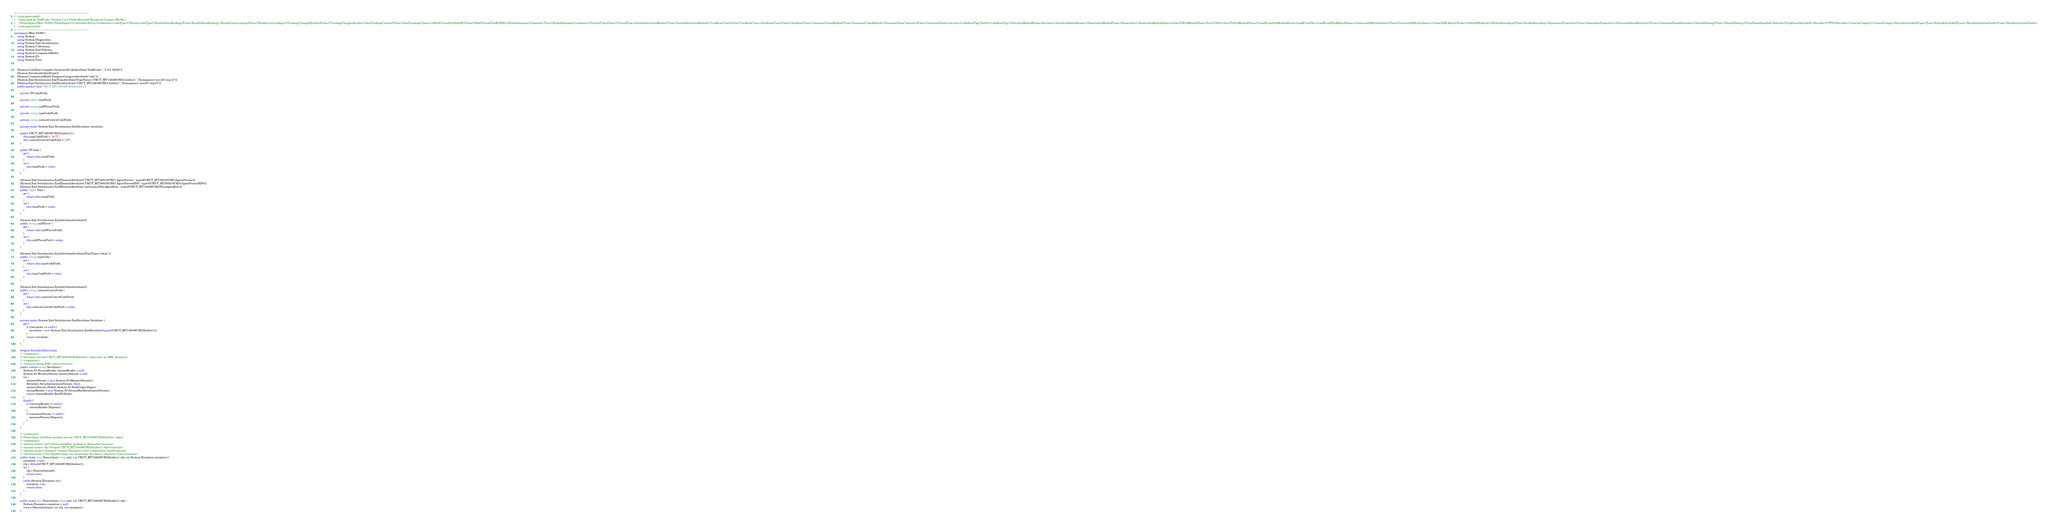Convert code to text. <code><loc_0><loc_0><loc_500><loc_500><_C#_>// ------------------------------------------------------------------------------
//  <auto-generated>
//    Generated by Xsd2Code. Version 3.4.0.18239 Microsoft Reciprocal License (Ms-RL) 
//    <NameSpace>Mim.V4200</NameSpace><Collection>Array</Collection><codeType>CSharp</codeType><EnableDataBinding>False</EnableDataBinding><EnableLazyLoading>False</EnableLazyLoading><TrackingChangesEnable>False</TrackingChangesEnable><GenTrackingClasses>False</GenTrackingClasses><HidePrivateFieldInIDE>False</HidePrivateFieldInIDE><EnableSummaryComment>True</EnableSummaryComment><VirtualProp>False</VirtualProp><IncludeSerializeMethod>True</IncludeSerializeMethod><UseBaseClass>False</UseBaseClass><GenBaseClass>False</GenBaseClass><GenerateCloneMethod>True</GenerateCloneMethod><GenerateDataContracts>False</GenerateDataContracts><CodeBaseTag>Net35</CodeBaseTag><SerializeMethodName>Serialize</SerializeMethodName><DeserializeMethodName>Deserialize</DeserializeMethodName><SaveToFileMethodName>SaveToFile</SaveToFileMethodName><LoadFromFileMethodName>LoadFromFile</LoadFromFileMethodName><GenerateXMLAttributes>True</GenerateXMLAttributes><OrderXMLAttrib>False</OrderXMLAttrib><EnableEncoding>False</EnableEncoding><AutomaticProperties>False</AutomaticProperties><GenerateShouldSerialize>False</GenerateShouldSerialize><DisableDebug>False</DisableDebug><PropNameSpecified>Default</PropNameSpecified><Encoder>UTF8</Encoder><CustomUsings></CustomUsings><ExcludeIncludedTypes>True</ExcludeIncludedTypes><EnableInitializeFields>False</EnableInitializeFields>
//  </auto-generated>
// ------------------------------------------------------------------------------
namespace Mim.V4200 {
    using System;
    using System.Diagnostics;
    using System.Xml.Serialization;
    using System.Collections;
    using System.Xml.Schema;
    using System.ComponentModel;
    using System.IO;
    using System.Text;
    
    
    [System.CodeDom.Compiler.GeneratedCodeAttribute("Xsd2Code", "3.4.0.18239")]
    [System.SerializableAttribute()]
    [System.ComponentModel.DesignerCategoryAttribute("code")]
    [System.Xml.Serialization.XmlTypeAttribute(TypeName="UKCT_MT144048UK02.Author1", Namespace="urn:hl7-org:v3")]
    [System.Xml.Serialization.XmlRootAttribute("UKCT_MT144048UK02.Author1", Namespace="urn:hl7-org:v3")]
    public partial class UKCT_MT144048UK02Author1 {
        
        private TS timeField;
        
        private object itemField;
        
        private string nullFlavorField;
        
        private string typeCodeField;
        
        private string contextControlCodeField;
        
        private static System.Xml.Serialization.XmlSerializer serializer;
        
        public UKCT_MT144048UK02Author1() {
            this.typeCodeField = "AUT";
            this.contextControlCodeField = "OP";
        }
        
        public TS time {
            get {
                return this.timeField;
            }
            set {
                this.timeField = value;
            }
        }
        
        [System.Xml.Serialization.XmlElementAttribute("UKCT_MT160018UK01.AgentPerson", typeof(UKCT_MT160018UK01AgentPerson))]
        [System.Xml.Serialization.XmlElementAttribute("UKCT_MT160018UK01.AgentPersonSDS", typeof(UKCT_MT160018UK01AgentPersonSDS))]
        [System.Xml.Serialization.XmlElementAttribute("participantNonAgentRole", typeof(UKCT_MT144048UK02NonAgentRole))]
        public object Item {
            get {
                return this.itemField;
            }
            set {
                this.itemField = value;
            }
        }
        
        [System.Xml.Serialization.XmlAttributeAttribute()]
        public string nullFlavor {
            get {
                return this.nullFlavorField;
            }
            set {
                this.nullFlavorField = value;
            }
        }
        
        [System.Xml.Serialization.XmlAttributeAttribute(DataType="token")]
        public string typeCode {
            get {
                return this.typeCodeField;
            }
            set {
                this.typeCodeField = value;
            }
        }
        
        [System.Xml.Serialization.XmlAttributeAttribute()]
        public string contextControlCode {
            get {
                return this.contextControlCodeField;
            }
            set {
                this.contextControlCodeField = value;
            }
        }
        
        private static System.Xml.Serialization.XmlSerializer Serializer {
            get {
                if ((serializer == null)) {
                    serializer = new System.Xml.Serialization.XmlSerializer(typeof(UKCT_MT144048UK02Author1));
                }
                return serializer;
            }
        }
        
        #region Serialize/Deserialize
        /// <summary>
        /// Serializes current UKCT_MT144048UK02Author1 object into an XML document
        /// </summary>
        /// <returns>string XML value</returns>
        public virtual string Serialize() {
            System.IO.StreamReader streamReader = null;
            System.IO.MemoryStream memoryStream = null;
            try {
                memoryStream = new System.IO.MemoryStream();
                Serializer.Serialize(memoryStream, this);
                memoryStream.Seek(0, System.IO.SeekOrigin.Begin);
                streamReader = new System.IO.StreamReader(memoryStream);
                return streamReader.ReadToEnd();
            }
            finally {
                if ((streamReader != null)) {
                    streamReader.Dispose();
                }
                if ((memoryStream != null)) {
                    memoryStream.Dispose();
                }
            }
        }
        
        /// <summary>
        /// Deserializes workflow markup into an UKCT_MT144048UK02Author1 object
        /// </summary>
        /// <param name="xml">string workflow markup to deserialize</param>
        /// <param name="obj">Output UKCT_MT144048UK02Author1 object</param>
        /// <param name="exception">output Exception value if deserialize failed</param>
        /// <returns>true if this XmlSerializer can deserialize the object; otherwise, false</returns>
        public static bool Deserialize(string xml, out UKCT_MT144048UK02Author1 obj, out System.Exception exception) {
            exception = null;
            obj = default(UKCT_MT144048UK02Author1);
            try {
                obj = Deserialize(xml);
                return true;
            }
            catch (System.Exception ex) {
                exception = ex;
                return false;
            }
        }
        
        public static bool Deserialize(string xml, out UKCT_MT144048UK02Author1 obj) {
            System.Exception exception = null;
            return Deserialize(xml, out obj, out exception);
        }
        </code> 